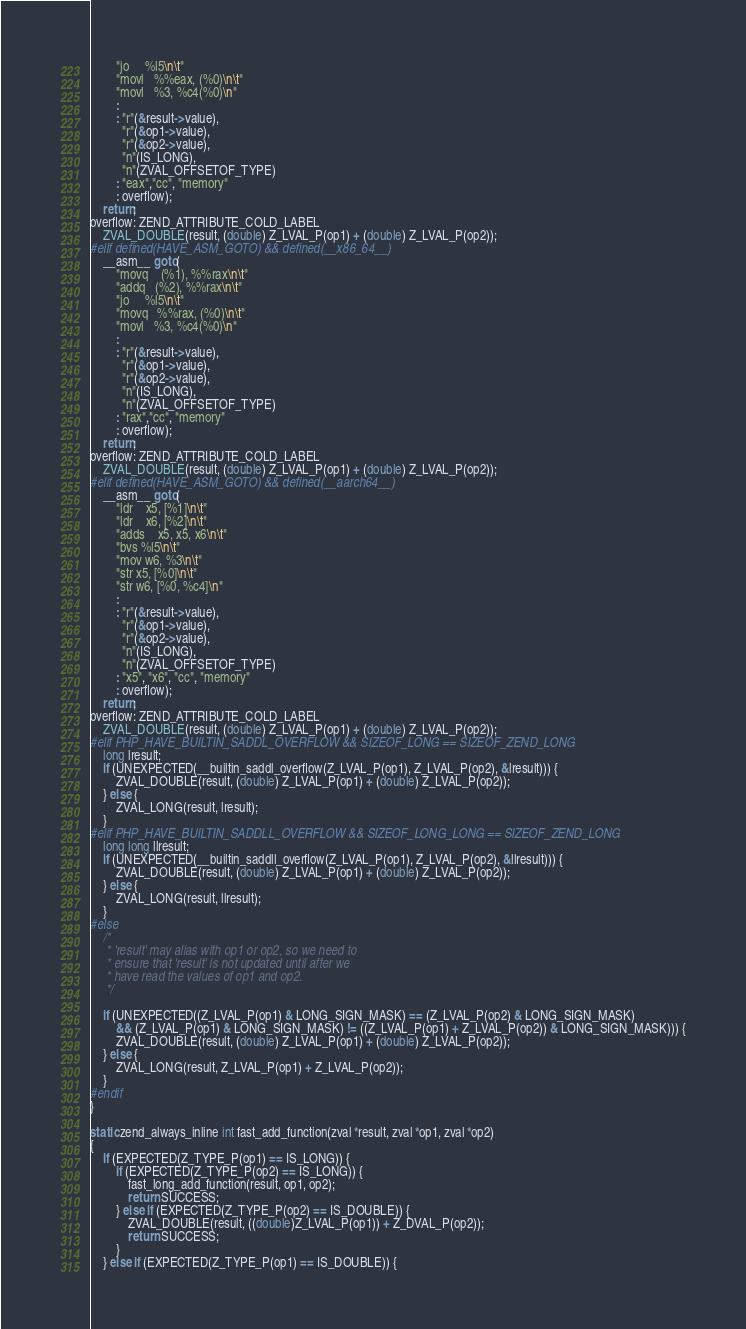<code> <loc_0><loc_0><loc_500><loc_500><_C_>		"jo     %l5\n\t"
		"movl   %%eax, (%0)\n\t"
		"movl   %3, %c4(%0)\n"
		:
		: "r"(&result->value),
		  "r"(&op1->value),
		  "r"(&op2->value),
		  "n"(IS_LONG),
		  "n"(ZVAL_OFFSETOF_TYPE)
		: "eax","cc", "memory"
		: overflow);
	return;
overflow: ZEND_ATTRIBUTE_COLD_LABEL
	ZVAL_DOUBLE(result, (double) Z_LVAL_P(op1) + (double) Z_LVAL_P(op2));
#elif defined(HAVE_ASM_GOTO) && defined(__x86_64__)
	__asm__ goto(
		"movq	(%1), %%rax\n\t"
		"addq   (%2), %%rax\n\t"
		"jo     %l5\n\t"
		"movq   %%rax, (%0)\n\t"
		"movl   %3, %c4(%0)\n"
		:
		: "r"(&result->value),
		  "r"(&op1->value),
		  "r"(&op2->value),
		  "n"(IS_LONG),
		  "n"(ZVAL_OFFSETOF_TYPE)
		: "rax","cc", "memory"
		: overflow);
	return;
overflow: ZEND_ATTRIBUTE_COLD_LABEL
	ZVAL_DOUBLE(result, (double) Z_LVAL_P(op1) + (double) Z_LVAL_P(op2));
#elif defined(HAVE_ASM_GOTO) && defined(__aarch64__)
	__asm__ goto(
		"ldr    x5, [%1]\n\t"
		"ldr    x6, [%2]\n\t"
		"adds	x5, x5, x6\n\t"
		"bvs	%l5\n\t"
		"mov	w6, %3\n\t"
		"str	x5, [%0]\n\t"
		"str	w6, [%0, %c4]\n"
		:
		: "r"(&result->value),
		  "r"(&op1->value),
		  "r"(&op2->value),
		  "n"(IS_LONG),
		  "n"(ZVAL_OFFSETOF_TYPE)
		: "x5", "x6", "cc", "memory"
		: overflow);
	return;
overflow: ZEND_ATTRIBUTE_COLD_LABEL
	ZVAL_DOUBLE(result, (double) Z_LVAL_P(op1) + (double) Z_LVAL_P(op2));
#elif PHP_HAVE_BUILTIN_SADDL_OVERFLOW && SIZEOF_LONG == SIZEOF_ZEND_LONG
	long lresult;
	if (UNEXPECTED(__builtin_saddl_overflow(Z_LVAL_P(op1), Z_LVAL_P(op2), &lresult))) {
		ZVAL_DOUBLE(result, (double) Z_LVAL_P(op1) + (double) Z_LVAL_P(op2));
	} else {
		ZVAL_LONG(result, lresult);
	}
#elif PHP_HAVE_BUILTIN_SADDLL_OVERFLOW && SIZEOF_LONG_LONG == SIZEOF_ZEND_LONG
	long long llresult;
	if (UNEXPECTED(__builtin_saddll_overflow(Z_LVAL_P(op1), Z_LVAL_P(op2), &llresult))) {
		ZVAL_DOUBLE(result, (double) Z_LVAL_P(op1) + (double) Z_LVAL_P(op2));
	} else {
		ZVAL_LONG(result, llresult);
	}
#else
	/*
	 * 'result' may alias with op1 or op2, so we need to
	 * ensure that 'result' is not updated until after we
	 * have read the values of op1 and op2.
	 */

	if (UNEXPECTED((Z_LVAL_P(op1) & LONG_SIGN_MASK) == (Z_LVAL_P(op2) & LONG_SIGN_MASK)
		&& (Z_LVAL_P(op1) & LONG_SIGN_MASK) != ((Z_LVAL_P(op1) + Z_LVAL_P(op2)) & LONG_SIGN_MASK))) {
		ZVAL_DOUBLE(result, (double) Z_LVAL_P(op1) + (double) Z_LVAL_P(op2));
	} else {
		ZVAL_LONG(result, Z_LVAL_P(op1) + Z_LVAL_P(op2));
	}
#endif
}

static zend_always_inline int fast_add_function(zval *result, zval *op1, zval *op2)
{
	if (EXPECTED(Z_TYPE_P(op1) == IS_LONG)) {
		if (EXPECTED(Z_TYPE_P(op2) == IS_LONG)) {
			fast_long_add_function(result, op1, op2);
			return SUCCESS;
		} else if (EXPECTED(Z_TYPE_P(op2) == IS_DOUBLE)) {
			ZVAL_DOUBLE(result, ((double)Z_LVAL_P(op1)) + Z_DVAL_P(op2));
			return SUCCESS;
		}
	} else if (EXPECTED(Z_TYPE_P(op1) == IS_DOUBLE)) {</code> 